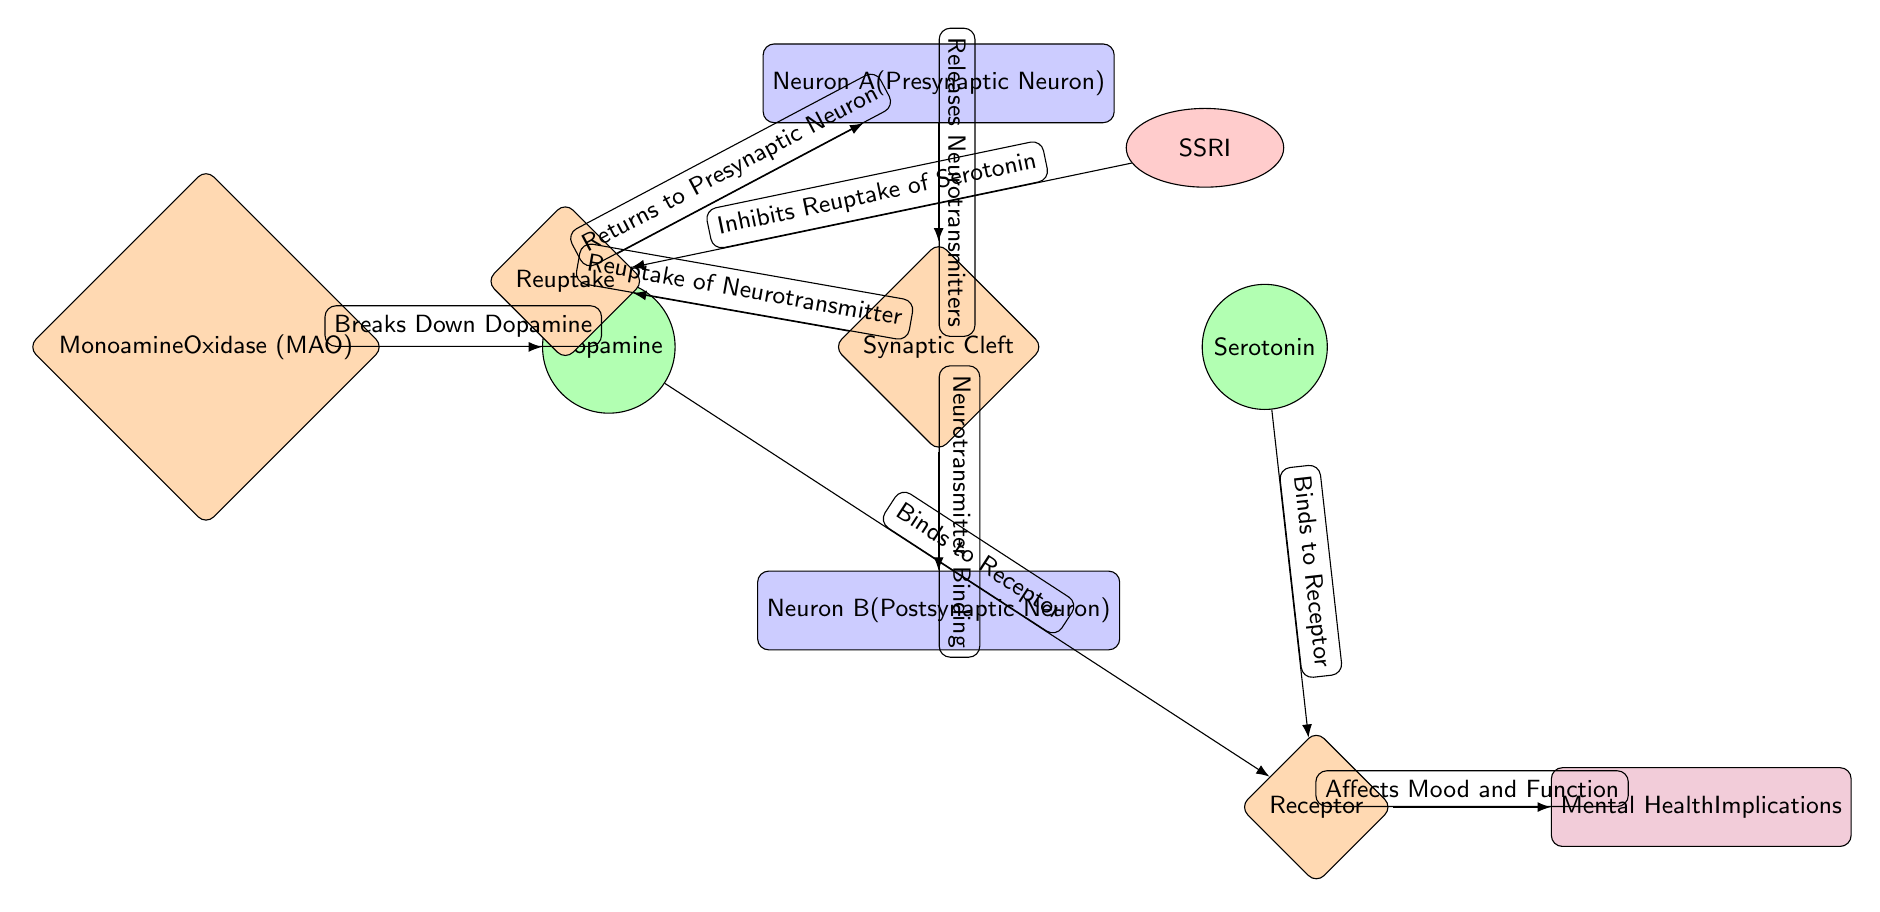What is the role of Neuron A? Neuron A is labeled as the "Presynaptic Neuron", indicating its function is to send neurotransmitters to the synaptic cleft.
Answer: Presynaptic Neuron How many neurotransmitters are shown in the diagram? The diagram features two neurotransmitters: Dopamine and Serotonin, which are displayed with separate nodes.
Answer: 2 What is the process that occurs in the synaptic cleft? The synaptic cleft is involved in both the release of neurotransmitters from Neuron A and their binding to Neuron B. This dual process is referenced in the diagram.
Answer: Neurotransmitter Binding What is the result of the Receptor binding with neurotransmitters? After binding, the Receptor affects mood and function, leading to mental health implications as indicated by the connection in the diagram.
Answer: Affects Mood and Function What inhibits the reuptake of serotonin in the diagram? The diagram shows that SSRIs inhibit the reuptake of serotonin, which affects its availability in the synaptic cleft.
Answer: SSRI What is the implication of the binding to the Receptor? The binding to the Receptor has mental health implications, suggesting that neurotransmitter interaction can influence mental well-being.
Answer: Mental Health Implications What does Monoamine Oxidase break down? The Monoamine Oxidase (MAO) enzyme breaks down Dopamine, as depicted in the diagram.
Answer: Dopamine What loop is created from the Reuptake process? The Reuptake process allows neurotransmitters to return to the presynaptic neuron (Neuron A), demonstrating a feedback loop in neurotransmitter handling.
Answer: Returns to Presynaptic Neuron 